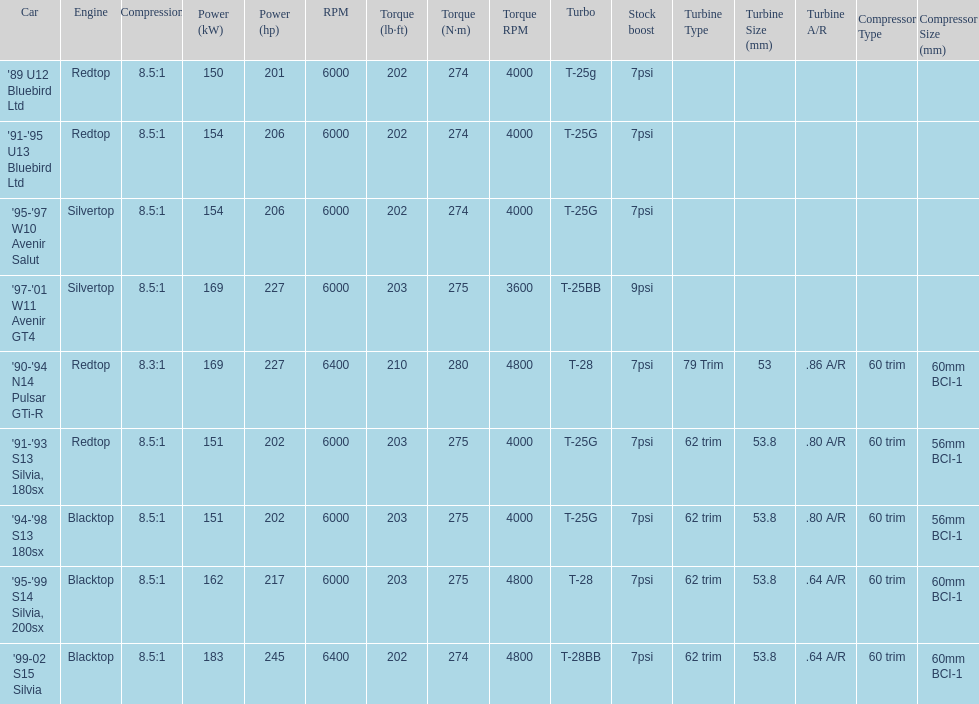Which car is the only one with more than 230 hp? '99-02 S15 Silvia. 